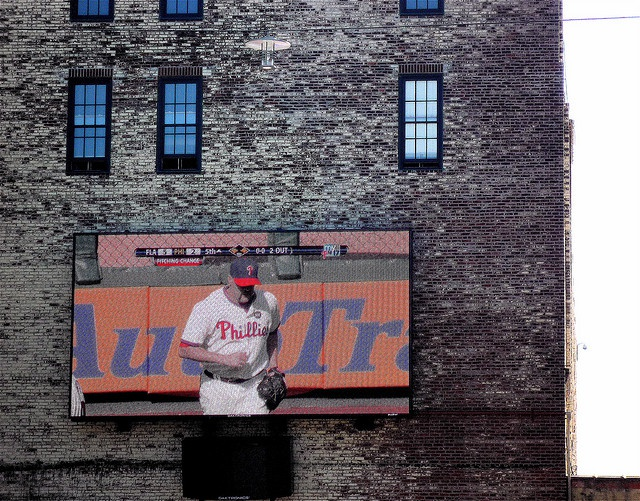Describe the objects in this image and their specific colors. I can see tv in gray, brown, black, and darkgray tones, people in gray, darkgray, lightgray, and brown tones, and baseball glove in gray, black, darkgray, and purple tones in this image. 